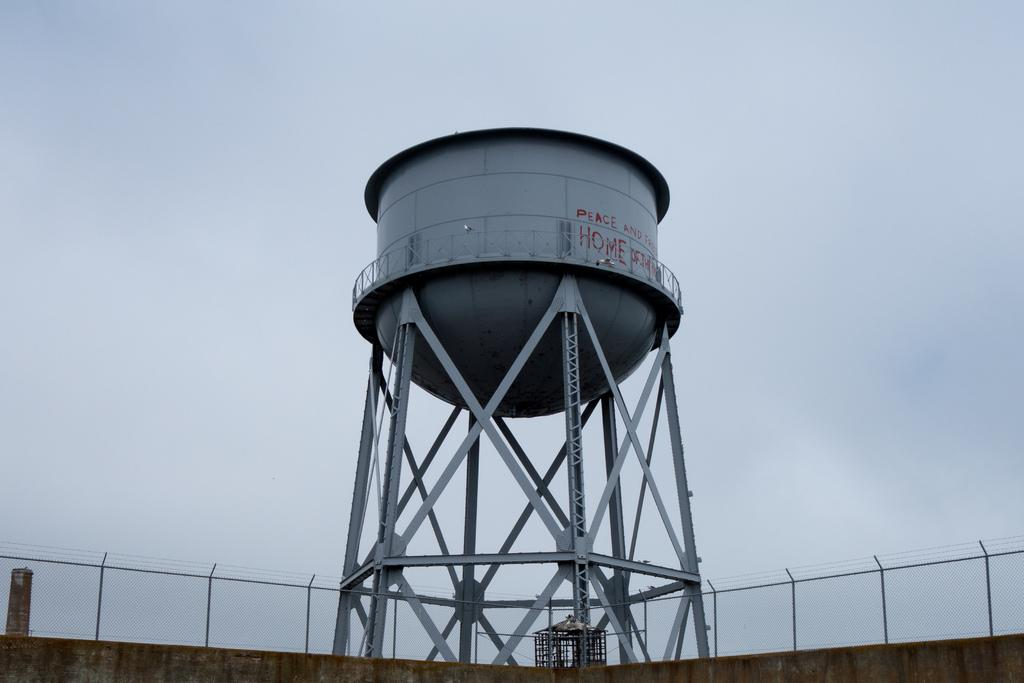What is the main structure visible in the image? There is an overhead tank in the image. What type of cooking equipment can be seen in the image? There are grills in the image. What type of barrier is present in the image? There is a fence in the image. What type of vertical structure is present in the image? There is a wall in the image. What is visible in the background of the image? The sky is visible in the background of the image. Can you see any ghosts interacting with the fence in the image? There are no ghosts present in the image. What type of sense can be seen in the image? There is no sense visible in the image; it is a still image. 